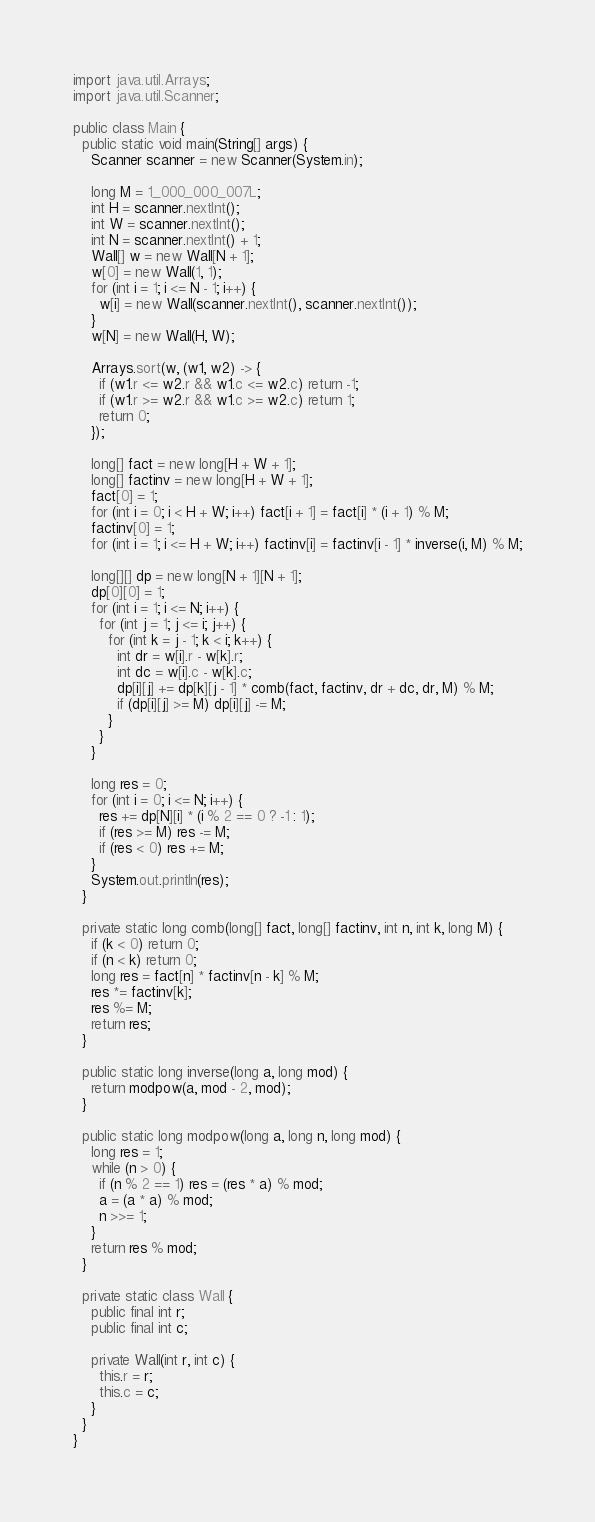<code> <loc_0><loc_0><loc_500><loc_500><_Java_>import java.util.Arrays;
import java.util.Scanner;

public class Main {
  public static void main(String[] args) {
    Scanner scanner = new Scanner(System.in);

    long M = 1_000_000_007L;
    int H = scanner.nextInt();
    int W = scanner.nextInt();
    int N = scanner.nextInt() + 1;
    Wall[] w = new Wall[N + 1];
    w[0] = new Wall(1, 1);
    for (int i = 1; i <= N - 1; i++) {
      w[i] = new Wall(scanner.nextInt(), scanner.nextInt());
    }
    w[N] = new Wall(H, W);

    Arrays.sort(w, (w1, w2) -> {
      if (w1.r <= w2.r && w1.c <= w2.c) return -1;
      if (w1.r >= w2.r && w1.c >= w2.c) return 1;
      return 0;
    });

    long[] fact = new long[H + W + 1];
    long[] factinv = new long[H + W + 1];
    fact[0] = 1;
    for (int i = 0; i < H + W; i++) fact[i + 1] = fact[i] * (i + 1) % M;
    factinv[0] = 1;
    for (int i = 1; i <= H + W; i++) factinv[i] = factinv[i - 1] * inverse(i, M) % M;

    long[][] dp = new long[N + 1][N + 1];
    dp[0][0] = 1;
    for (int i = 1; i <= N; i++) {
      for (int j = 1; j <= i; j++) {
        for (int k = j - 1; k < i; k++) {
          int dr = w[i].r - w[k].r;
          int dc = w[i].c - w[k].c;
          dp[i][j] += dp[k][j - 1] * comb(fact, factinv, dr + dc, dr, M) % M;
          if (dp[i][j] >= M) dp[i][j] -= M;
        }
      }
    }

    long res = 0;
    for (int i = 0; i <= N; i++) {
      res += dp[N][i] * (i % 2 == 0 ? -1 : 1);
      if (res >= M) res -= M;
      if (res < 0) res += M;
    }
    System.out.println(res);
  }

  private static long comb(long[] fact, long[] factinv, int n, int k, long M) {
    if (k < 0) return 0;
    if (n < k) return 0;
    long res = fact[n] * factinv[n - k] % M;
    res *= factinv[k];
    res %= M;
    return res;
  }

  public static long inverse(long a, long mod) {
    return modpow(a, mod - 2, mod);
  }

  public static long modpow(long a, long n, long mod) {
    long res = 1;
    while (n > 0) {
      if (n % 2 == 1) res = (res * a) % mod;
      a = (a * a) % mod;
      n >>= 1;
    }
    return res % mod;
  }

  private static class Wall {
    public final int r;
    public final int c;

    private Wall(int r, int c) {
      this.r = r;
      this.c = c;
    }
  }
}
</code> 